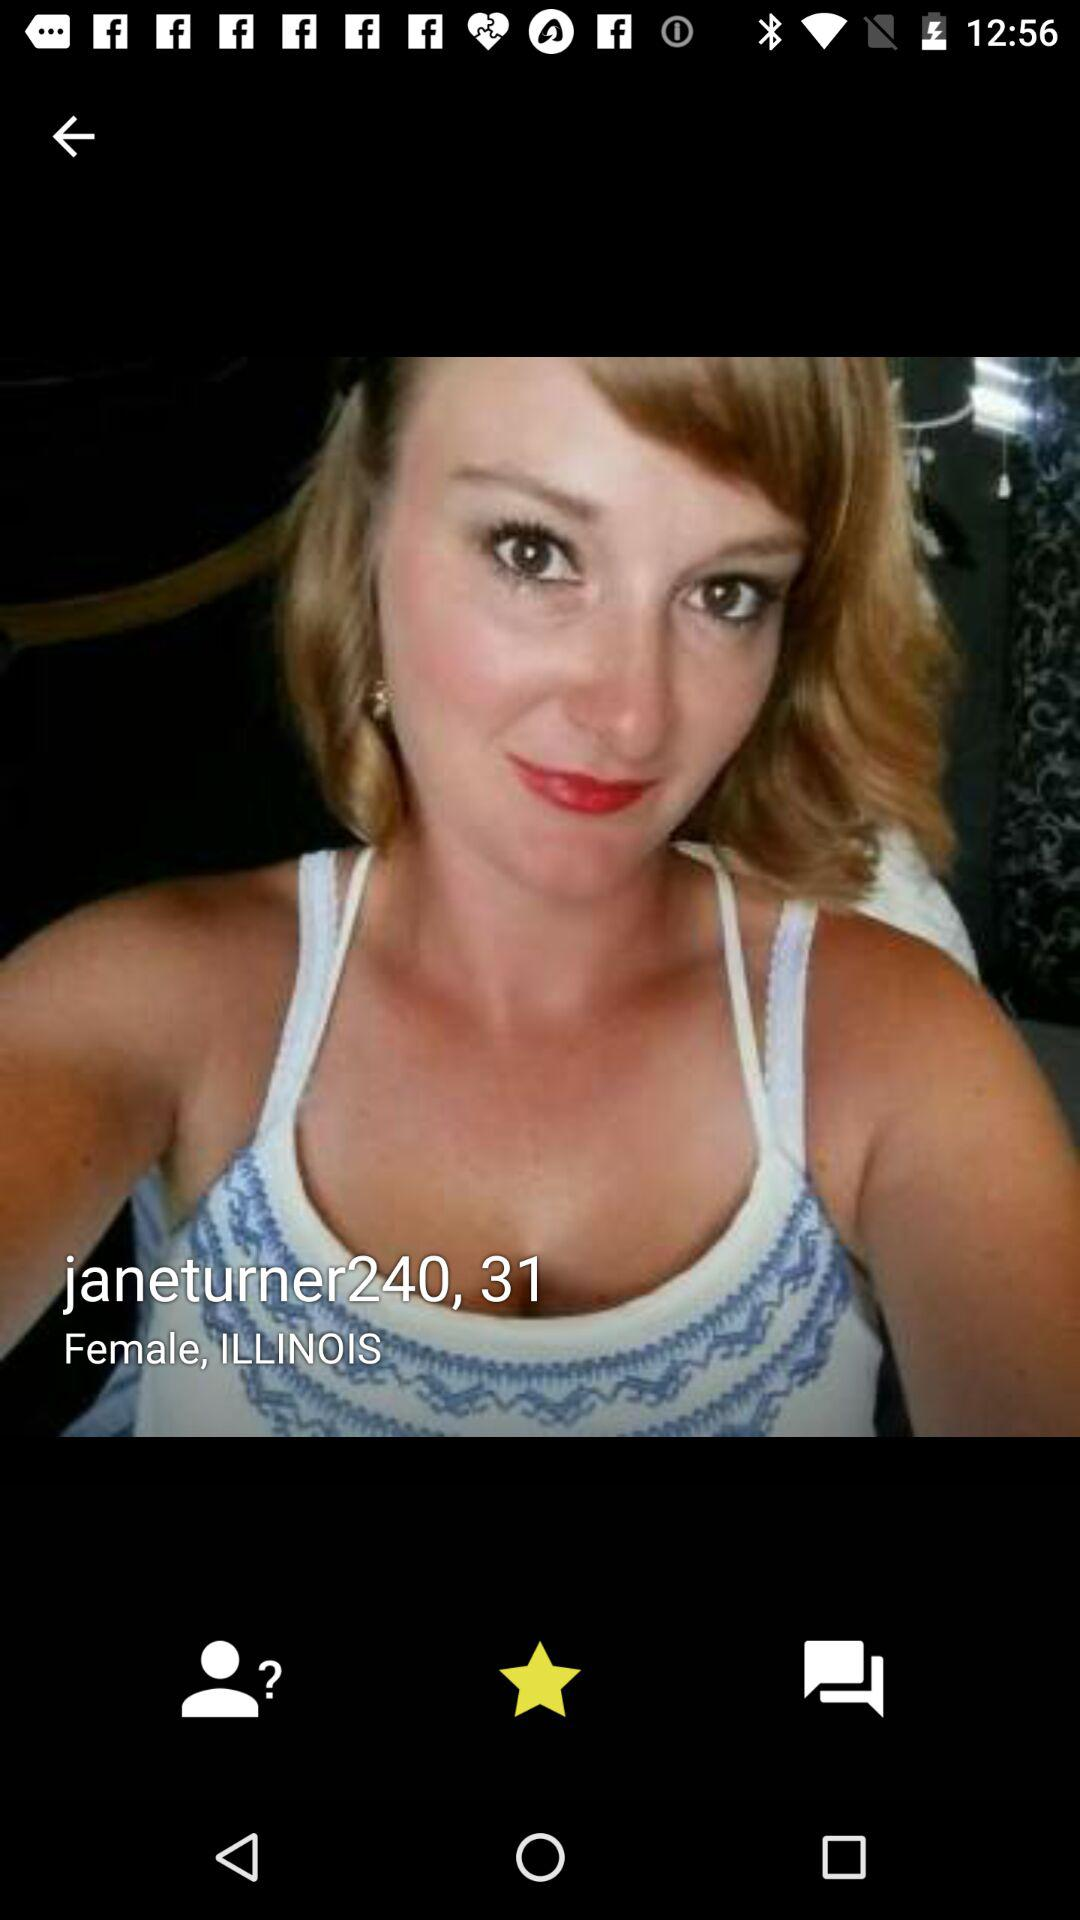In which city is the user located?
When the provided information is insufficient, respond with <no answer>. <no answer> 